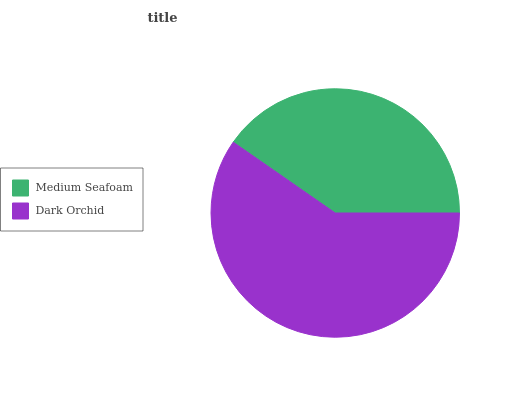Is Medium Seafoam the minimum?
Answer yes or no. Yes. Is Dark Orchid the maximum?
Answer yes or no. Yes. Is Dark Orchid the minimum?
Answer yes or no. No. Is Dark Orchid greater than Medium Seafoam?
Answer yes or no. Yes. Is Medium Seafoam less than Dark Orchid?
Answer yes or no. Yes. Is Medium Seafoam greater than Dark Orchid?
Answer yes or no. No. Is Dark Orchid less than Medium Seafoam?
Answer yes or no. No. Is Dark Orchid the high median?
Answer yes or no. Yes. Is Medium Seafoam the low median?
Answer yes or no. Yes. Is Medium Seafoam the high median?
Answer yes or no. No. Is Dark Orchid the low median?
Answer yes or no. No. 